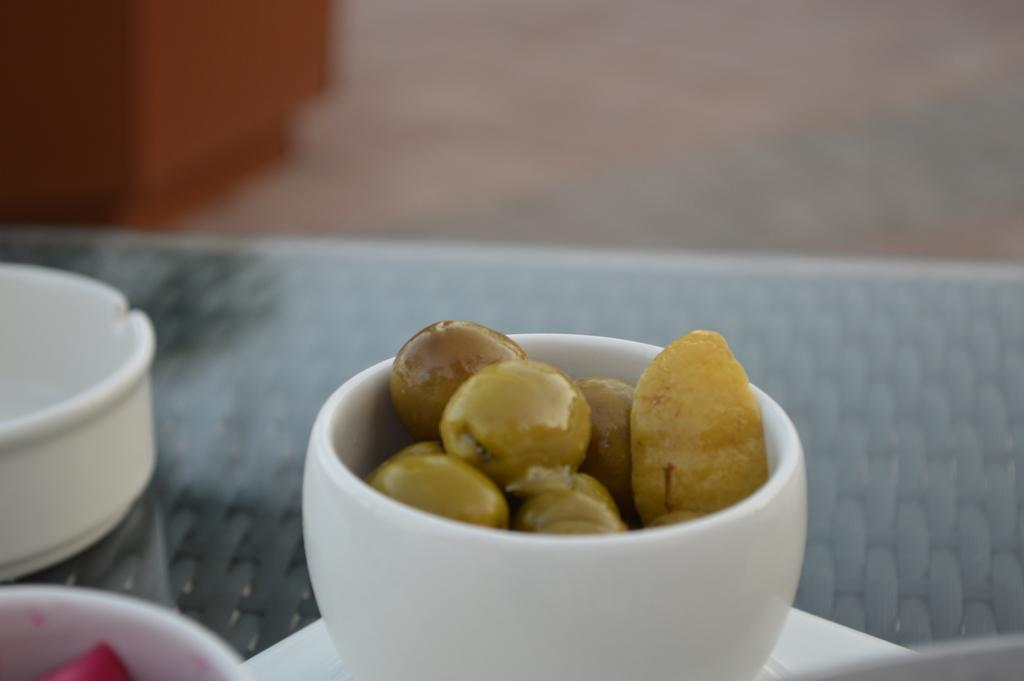What objects are present in the image? There are bowls in the image. What else can be seen in the image besides the bowls? There is food in the image. Can you describe the background of the image? The background of the image is blurred. What type of stone is visible in the image? There is no stone present in the image. What tasks is the secretary performing in the image? There is no secretary present in the image. 